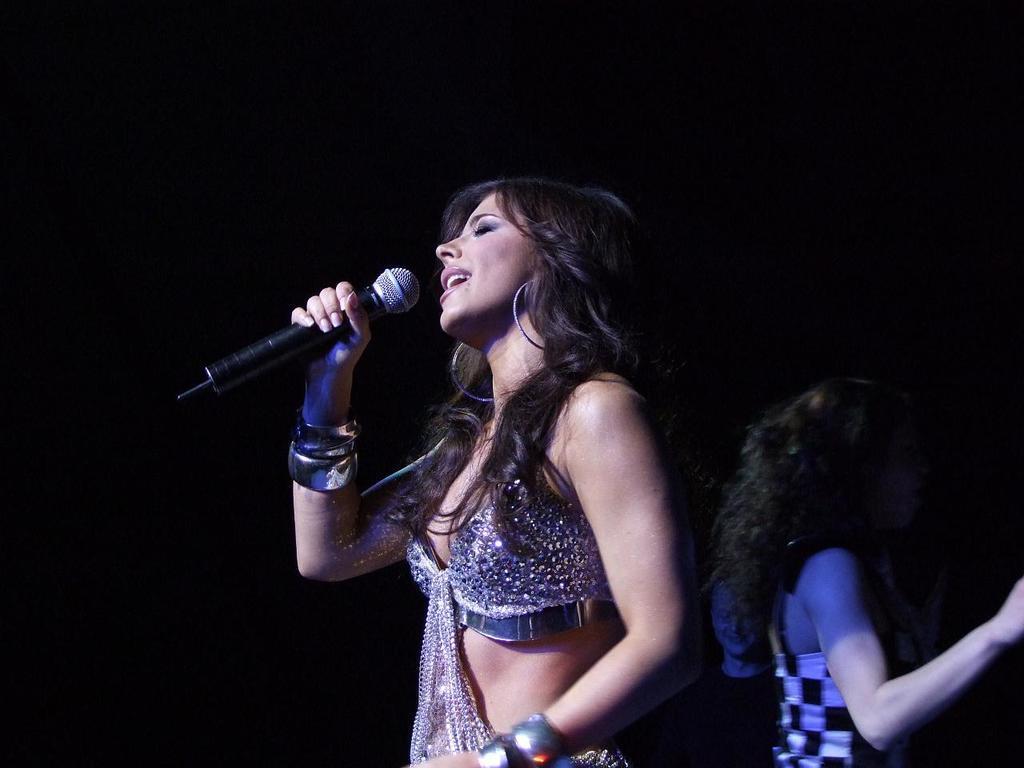In one or two sentences, can you explain what this image depicts? In the center of the picture there is a woman standing holding a microphone, she is singing. To the right there is another woman. Background is dark. 